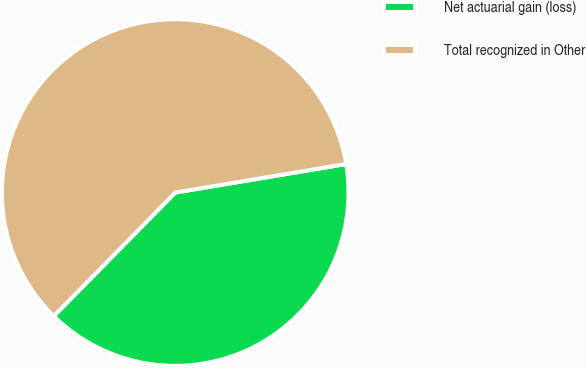Convert chart to OTSL. <chart><loc_0><loc_0><loc_500><loc_500><pie_chart><fcel>Net actuarial gain (loss)<fcel>Total recognized in Other<nl><fcel>40.0%<fcel>60.0%<nl></chart> 